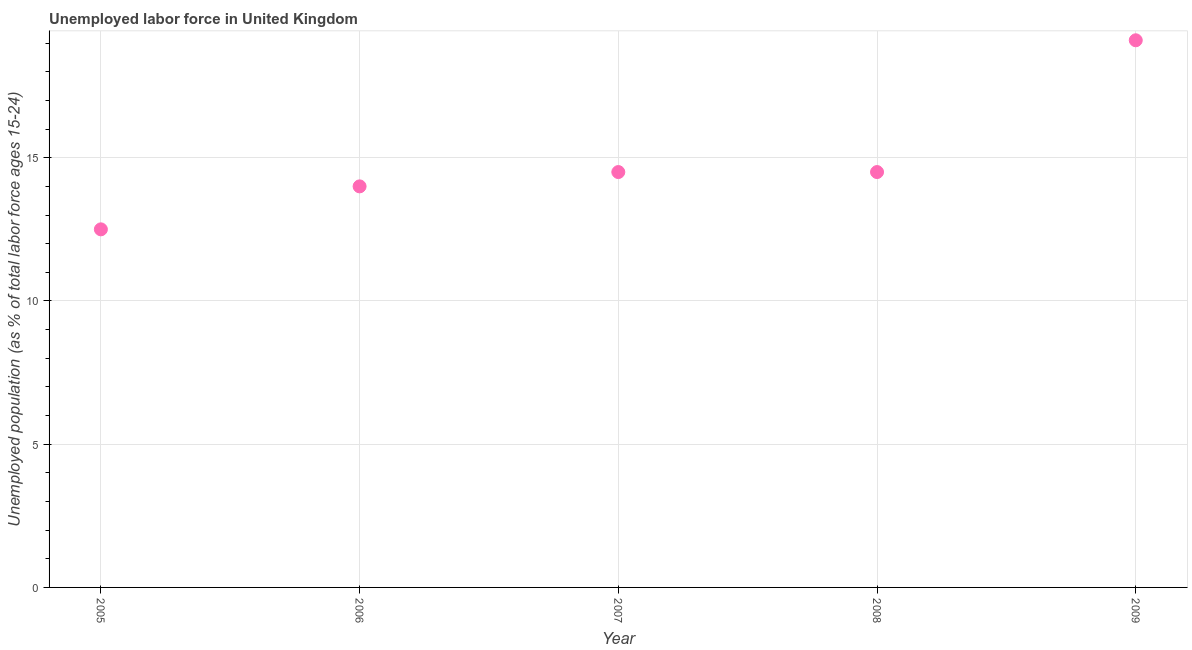Across all years, what is the maximum total unemployed youth population?
Your response must be concise. 19.1. What is the sum of the total unemployed youth population?
Your answer should be very brief. 74.6. What is the difference between the total unemployed youth population in 2005 and 2006?
Your response must be concise. -1.5. What is the average total unemployed youth population per year?
Offer a terse response. 14.92. What is the median total unemployed youth population?
Keep it short and to the point. 14.5. Do a majority of the years between 2005 and 2007 (inclusive) have total unemployed youth population greater than 16 %?
Ensure brevity in your answer.  No. What is the ratio of the total unemployed youth population in 2005 to that in 2009?
Offer a terse response. 0.65. Is the total unemployed youth population in 2005 less than that in 2009?
Your answer should be very brief. Yes. Is the difference between the total unemployed youth population in 2007 and 2009 greater than the difference between any two years?
Give a very brief answer. No. What is the difference between the highest and the second highest total unemployed youth population?
Your response must be concise. 4.6. Is the sum of the total unemployed youth population in 2006 and 2009 greater than the maximum total unemployed youth population across all years?
Make the answer very short. Yes. What is the difference between the highest and the lowest total unemployed youth population?
Give a very brief answer. 6.6. In how many years, is the total unemployed youth population greater than the average total unemployed youth population taken over all years?
Keep it short and to the point. 1. Does the total unemployed youth population monotonically increase over the years?
Provide a short and direct response. No. How many dotlines are there?
Make the answer very short. 1. How many years are there in the graph?
Make the answer very short. 5. Are the values on the major ticks of Y-axis written in scientific E-notation?
Offer a terse response. No. What is the title of the graph?
Your answer should be very brief. Unemployed labor force in United Kingdom. What is the label or title of the Y-axis?
Give a very brief answer. Unemployed population (as % of total labor force ages 15-24). What is the Unemployed population (as % of total labor force ages 15-24) in 2009?
Your response must be concise. 19.1. What is the difference between the Unemployed population (as % of total labor force ages 15-24) in 2005 and 2006?
Ensure brevity in your answer.  -1.5. What is the difference between the Unemployed population (as % of total labor force ages 15-24) in 2005 and 2008?
Make the answer very short. -2. What is the difference between the Unemployed population (as % of total labor force ages 15-24) in 2006 and 2009?
Provide a succinct answer. -5.1. What is the difference between the Unemployed population (as % of total labor force ages 15-24) in 2007 and 2008?
Provide a short and direct response. 0. What is the difference between the Unemployed population (as % of total labor force ages 15-24) in 2007 and 2009?
Offer a terse response. -4.6. What is the difference between the Unemployed population (as % of total labor force ages 15-24) in 2008 and 2009?
Your answer should be very brief. -4.6. What is the ratio of the Unemployed population (as % of total labor force ages 15-24) in 2005 to that in 2006?
Provide a succinct answer. 0.89. What is the ratio of the Unemployed population (as % of total labor force ages 15-24) in 2005 to that in 2007?
Provide a short and direct response. 0.86. What is the ratio of the Unemployed population (as % of total labor force ages 15-24) in 2005 to that in 2008?
Give a very brief answer. 0.86. What is the ratio of the Unemployed population (as % of total labor force ages 15-24) in 2005 to that in 2009?
Provide a short and direct response. 0.65. What is the ratio of the Unemployed population (as % of total labor force ages 15-24) in 2006 to that in 2007?
Your answer should be very brief. 0.97. What is the ratio of the Unemployed population (as % of total labor force ages 15-24) in 2006 to that in 2008?
Provide a succinct answer. 0.97. What is the ratio of the Unemployed population (as % of total labor force ages 15-24) in 2006 to that in 2009?
Your response must be concise. 0.73. What is the ratio of the Unemployed population (as % of total labor force ages 15-24) in 2007 to that in 2009?
Your answer should be compact. 0.76. What is the ratio of the Unemployed population (as % of total labor force ages 15-24) in 2008 to that in 2009?
Provide a succinct answer. 0.76. 